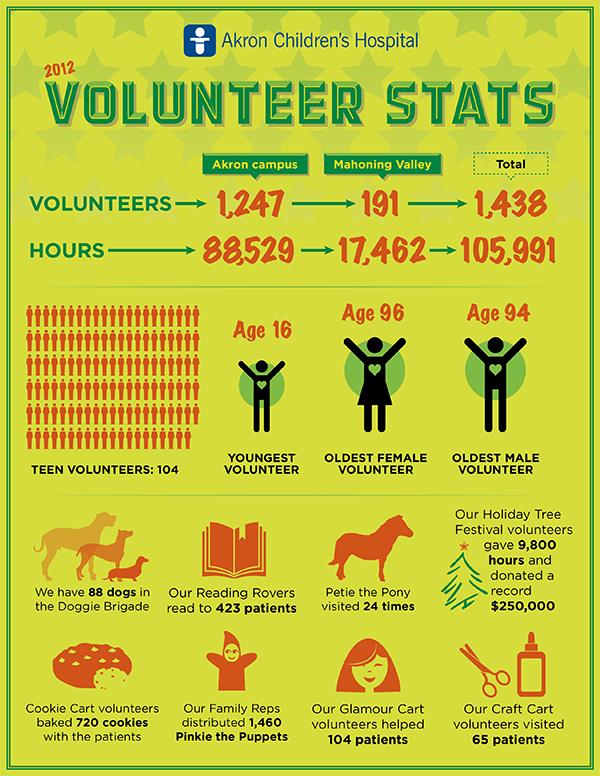Draw attention to some important aspects in this diagram. The oldest male volunteer at Akron Children's Hospital in 2012 was 94 years old. In 2012, the oldest female volunteer at Akron Children's Hospital was 96 years old. In 2012, a total of 88,529 hours were dedicated by volunteers at the Akron campus. In 2012, a total of 191 volunteers dedicated themselves to working in the Mahoning Valley. In 2012, a total of 105,991 hours were dedicated by volunteers at Akron Children's Hospital. 